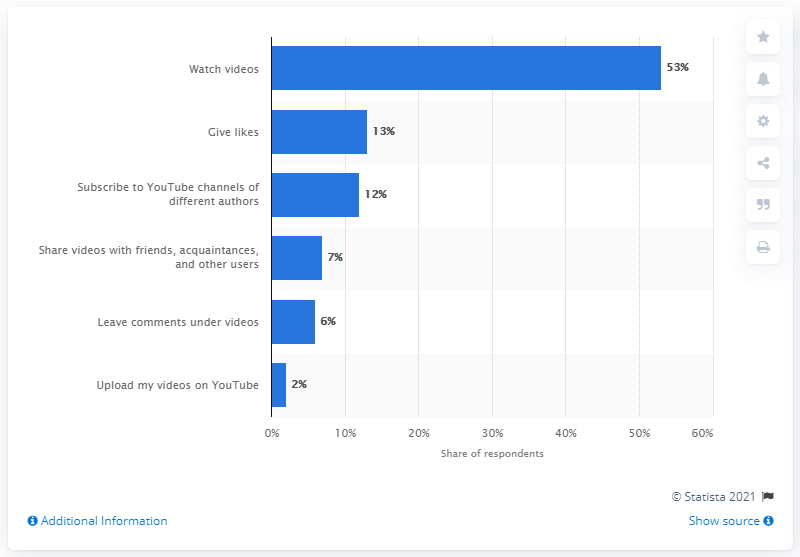Draw attention to some important aspects in this diagram. According to a survey conducted in 2019, a significant 53% of Russians used YouTube to watch videos. 